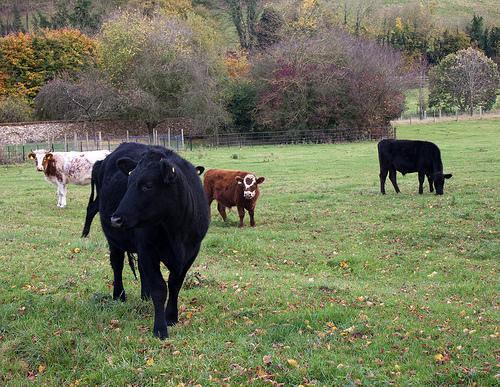How many cows are black?
Give a very brief answer. 2. How many animals are there?
Give a very brief answer. 4. How many black cows are there?
Give a very brief answer. 2. 